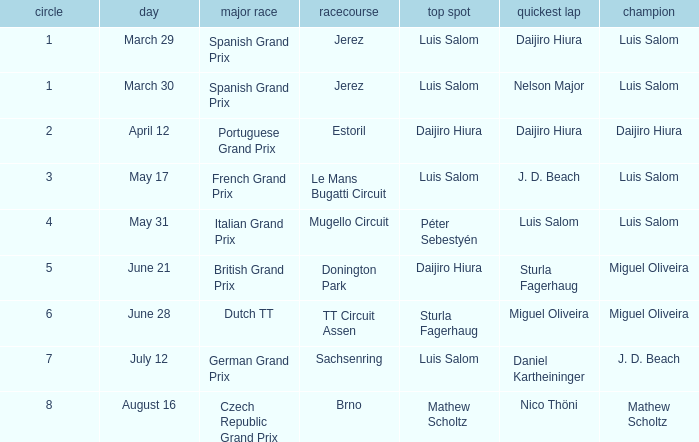Which round 5 Grand Prix had Daijiro Hiura at pole position?  British Grand Prix. 